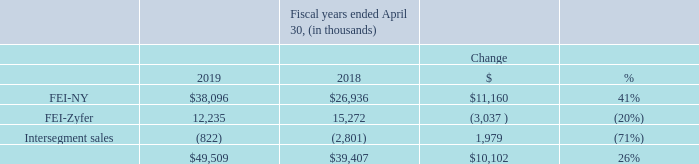Revenues
Fiscal 2019 revenues from satellite programs, one of the Company’s largest business area, increased by $8.6 million, or 61%, compared to the prior fiscal year. For Fiscal 2019 satellite program revenues for government end use were 46% of total revenues as compared to 36% for the prior fiscal year. Satellite program revenues for commercial end use were 5% and 14% of total revenue for Fiscal 2019 and Fiscal 2018, respectively. Revenues on satellite program contracts are recorded in the FEI-NY segment and are recognized primarily under the POC method. Sales revenues from non-space U.S. Government/DOD customers increased by approximately $5.2 million or 29% in Fiscal 2019 compared to prior fiscal year. These revenues are recorded in both the FEI-NY and FEI-Zyfer segments and accounted for approximately 46% and 45% of consolidated revenues for fiscal years 2019 and 2018, respectively. For the year ended April 30, 2019, other commercial and industrial sales accounted for approximately 8% of consolidated revenues compared to approximately 19% for fiscal year 2018. Sales in this business area were $3.9 million for the year ended April 30, 2019 compared to $7.6 million for the preceding year. Changes in revenue for the current year are partially due to implementation of ASU 2014-09 (see Note 1 to the Consolidated Financial Statements).
What is the amount of revenue from FEI-NY in 2018 and 2019 respectively?
Answer scale should be: thousand. 26,936, 38,096. What is the amount of revenue from FEI-Zyfer in 2018 and 2019 respectively?
Answer scale should be: thousand. 15,272, 12,235. How much did revenues from satellite programs change in 2019? Increased by $8.6 million, or 61%, compared to the prior fiscal year. In fiscal year 2019, what is the percentage constitution of revenues from FEI-NY among the total revenue?
Answer scale should be: percent. 38,096/49,509
Answer: 76.95. In fiscal year 2018, what is the percentage constitution of revenues from FEI-Zyfer among the total revenue?
Answer scale should be: percent. 15,272/39,407
Answer: 38.75. What is the average total revenue for fiscal years 2018 and 2019?
Answer scale should be: thousand. (49,509+39,407)/2
Answer: 44458. 